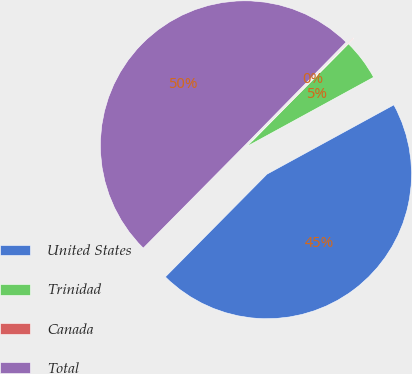<chart> <loc_0><loc_0><loc_500><loc_500><pie_chart><fcel>United States<fcel>Trinidad<fcel>Canada<fcel>Total<nl><fcel>45.37%<fcel>4.63%<fcel>0.07%<fcel>49.93%<nl></chart> 